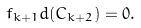<formula> <loc_0><loc_0><loc_500><loc_500>f _ { k + 1 } d ( C _ { k + 2 } ) = 0 .</formula> 